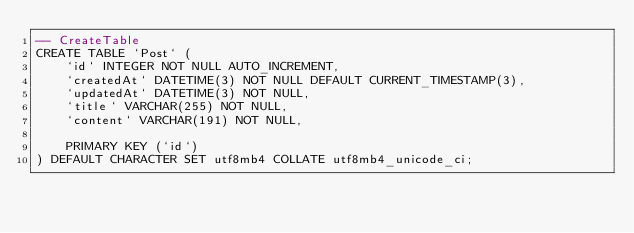Convert code to text. <code><loc_0><loc_0><loc_500><loc_500><_SQL_>-- CreateTable
CREATE TABLE `Post` (
    `id` INTEGER NOT NULL AUTO_INCREMENT,
    `createdAt` DATETIME(3) NOT NULL DEFAULT CURRENT_TIMESTAMP(3),
    `updatedAt` DATETIME(3) NOT NULL,
    `title` VARCHAR(255) NOT NULL,
    `content` VARCHAR(191) NOT NULL,

    PRIMARY KEY (`id`)
) DEFAULT CHARACTER SET utf8mb4 COLLATE utf8mb4_unicode_ci;
</code> 